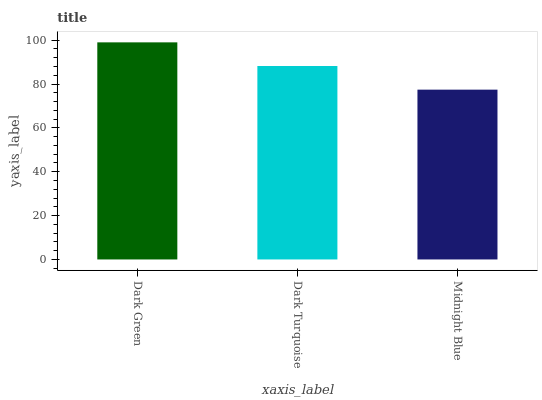Is Midnight Blue the minimum?
Answer yes or no. Yes. Is Dark Green the maximum?
Answer yes or no. Yes. Is Dark Turquoise the minimum?
Answer yes or no. No. Is Dark Turquoise the maximum?
Answer yes or no. No. Is Dark Green greater than Dark Turquoise?
Answer yes or no. Yes. Is Dark Turquoise less than Dark Green?
Answer yes or no. Yes. Is Dark Turquoise greater than Dark Green?
Answer yes or no. No. Is Dark Green less than Dark Turquoise?
Answer yes or no. No. Is Dark Turquoise the high median?
Answer yes or no. Yes. Is Dark Turquoise the low median?
Answer yes or no. Yes. Is Dark Green the high median?
Answer yes or no. No. Is Midnight Blue the low median?
Answer yes or no. No. 